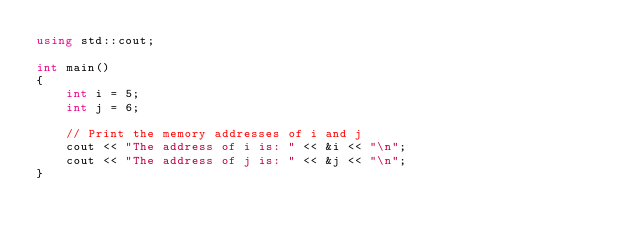Convert code to text. <code><loc_0><loc_0><loc_500><loc_500><_C++_>using std::cout;

int main()
{
    int i = 5;
    int j = 6;

    // Print the memory addresses of i and j
    cout << "The address of i is: " << &i << "\n";
    cout << "The address of j is: " << &j << "\n";
}</code> 